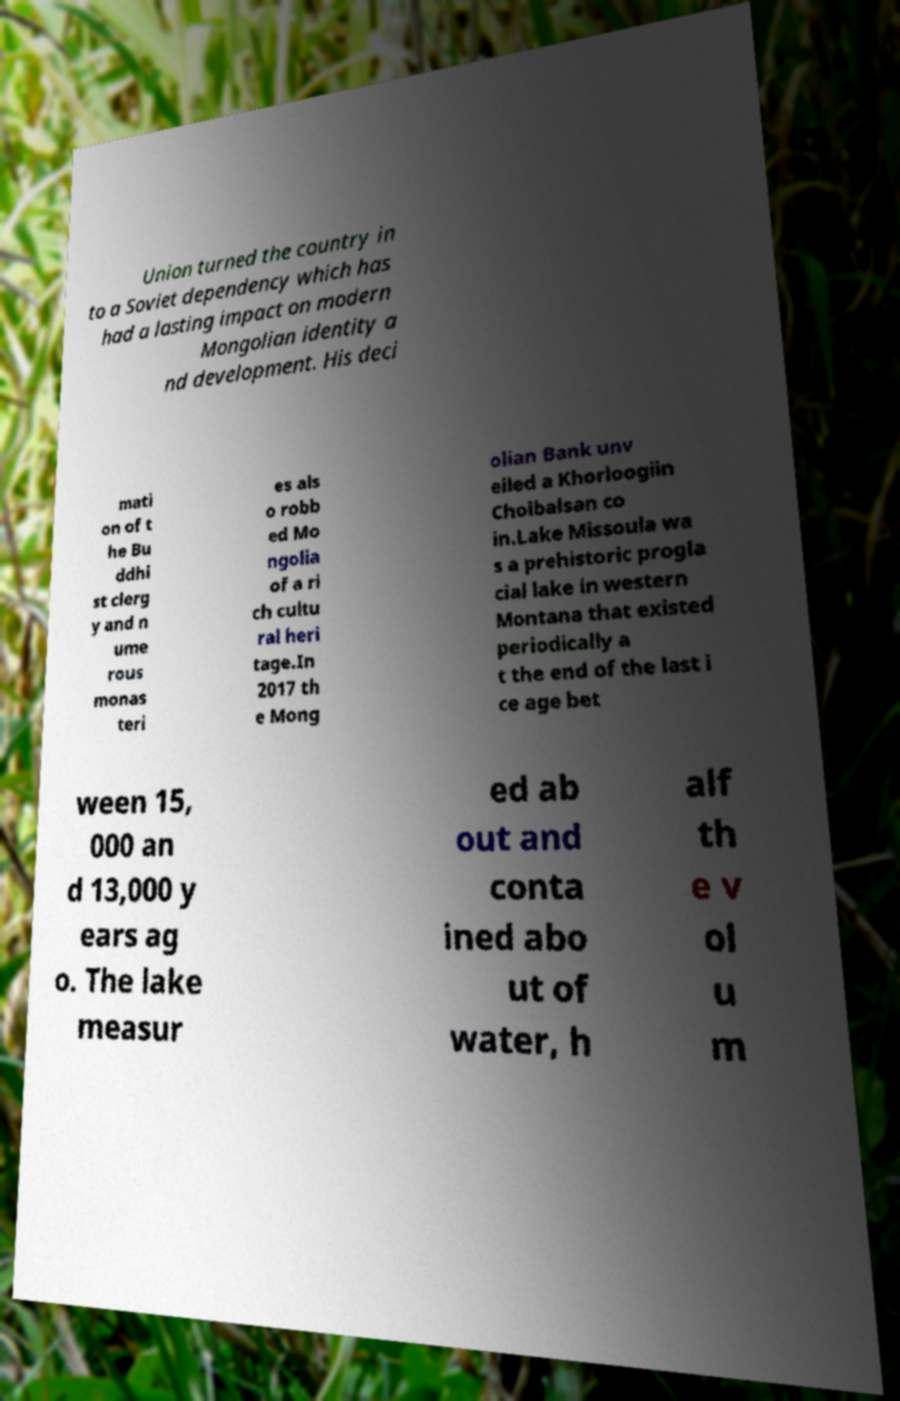What messages or text are displayed in this image? I need them in a readable, typed format. Union turned the country in to a Soviet dependency which has had a lasting impact on modern Mongolian identity a nd development. His deci mati on of t he Bu ddhi st clerg y and n ume rous monas teri es als o robb ed Mo ngolia of a ri ch cultu ral heri tage.In 2017 th e Mong olian Bank unv eiled a Khorloogiin Choibalsan co in.Lake Missoula wa s a prehistoric progla cial lake in western Montana that existed periodically a t the end of the last i ce age bet ween 15, 000 an d 13,000 y ears ag o. The lake measur ed ab out and conta ined abo ut of water, h alf th e v ol u m 